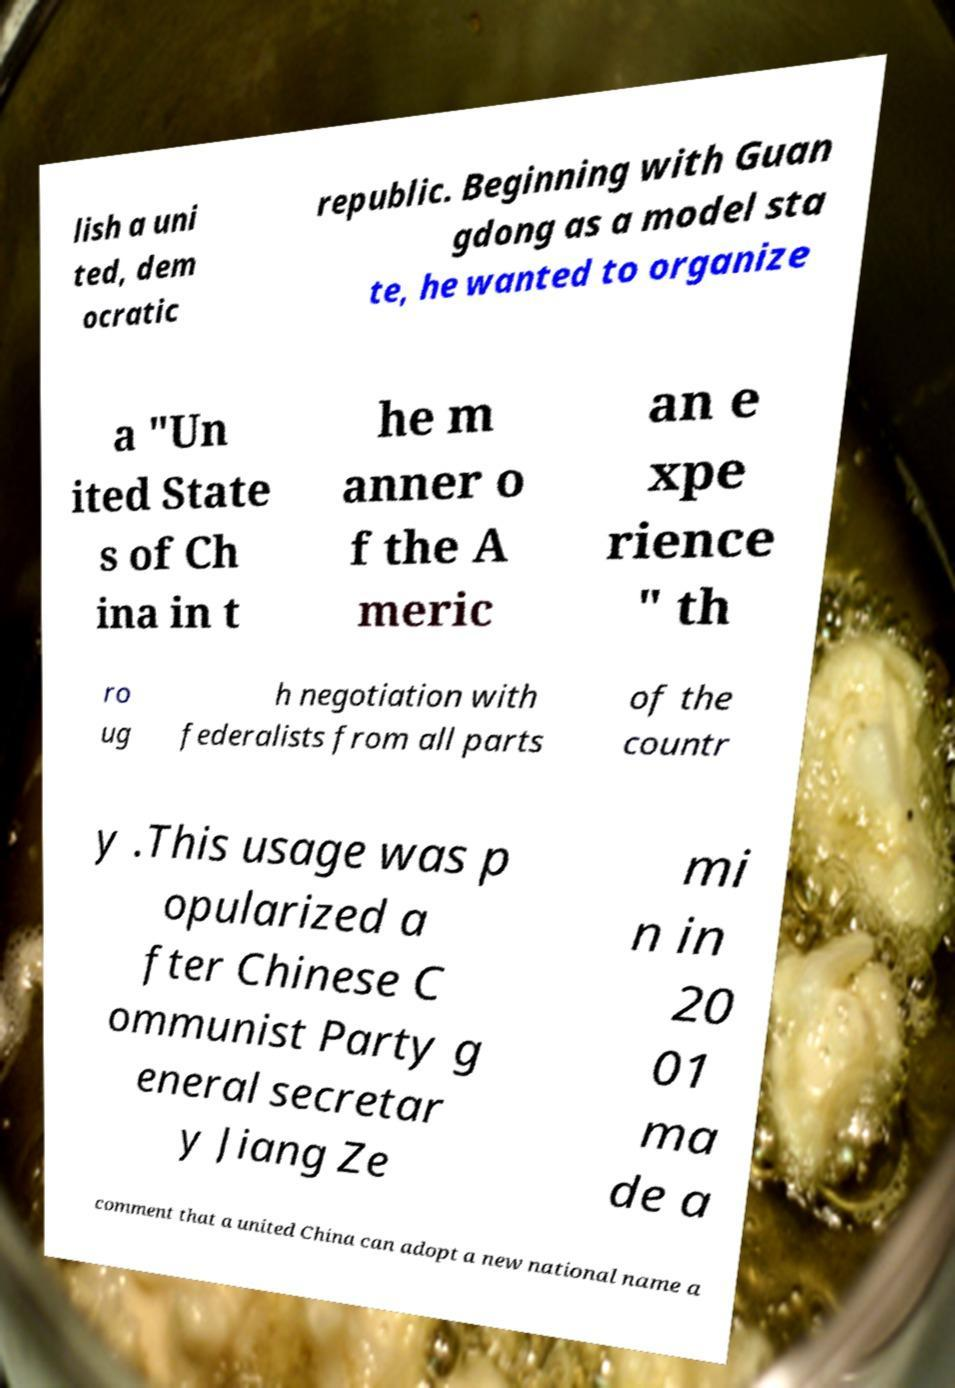Please read and relay the text visible in this image. What does it say? lish a uni ted, dem ocratic republic. Beginning with Guan gdong as a model sta te, he wanted to organize a "Un ited State s of Ch ina in t he m anner o f the A meric an e xpe rience " th ro ug h negotiation with federalists from all parts of the countr y .This usage was p opularized a fter Chinese C ommunist Party g eneral secretar y Jiang Ze mi n in 20 01 ma de a comment that a united China can adopt a new national name a 